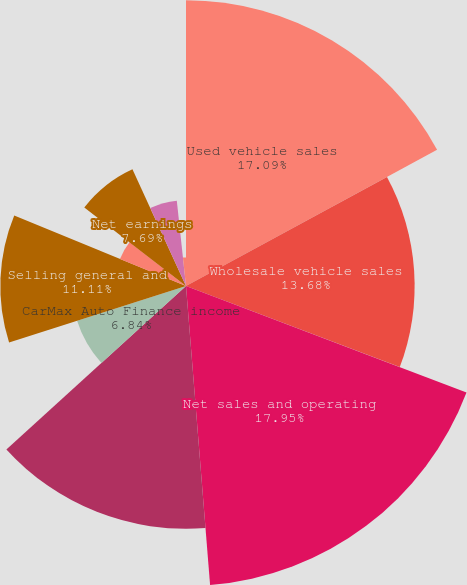Convert chart to OTSL. <chart><loc_0><loc_0><loc_500><loc_500><pie_chart><fcel>Used vehicle sales<fcel>Wholesale vehicle sales<fcel>Net sales and operating<fcel>Gross profit<fcel>CarMax Auto Finance income<fcel>Selling general and<fcel>Interest expense<fcel>Net earnings<fcel>Weighted average diluted<fcel>Diluted net earnings per share<nl><fcel>17.09%<fcel>13.68%<fcel>17.95%<fcel>14.53%<fcel>6.84%<fcel>11.11%<fcel>4.27%<fcel>7.69%<fcel>5.13%<fcel>1.71%<nl></chart> 